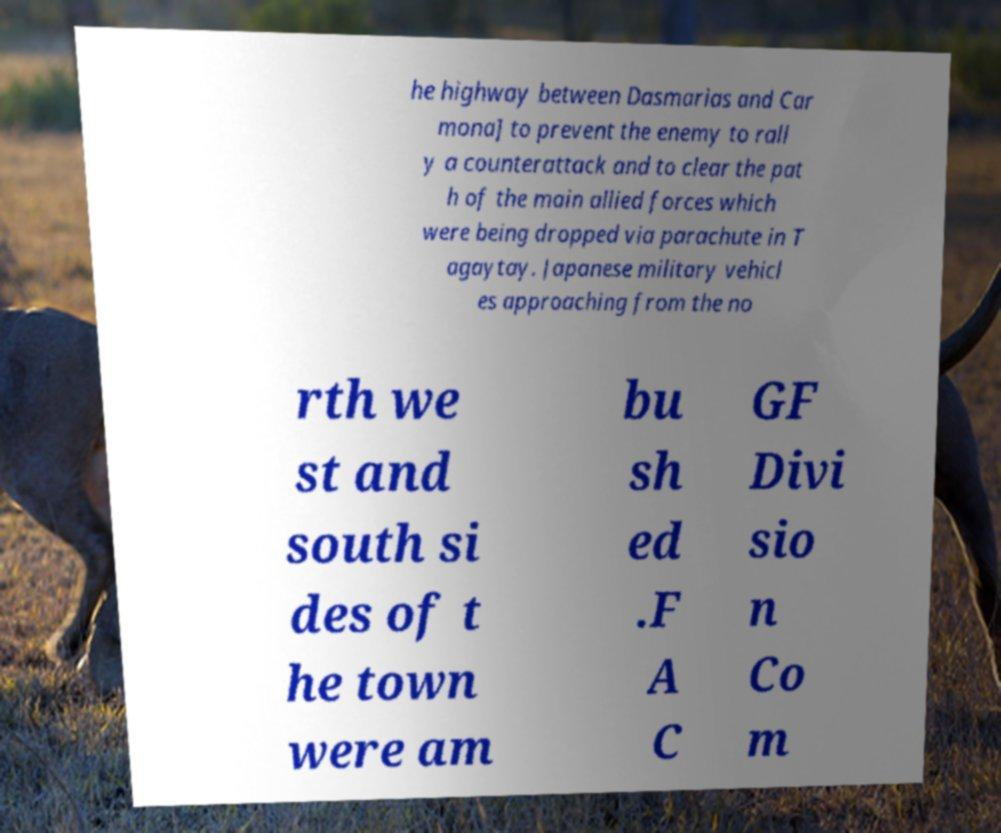What messages or text are displayed in this image? I need them in a readable, typed format. he highway between Dasmarias and Car mona] to prevent the enemy to rall y a counterattack and to clear the pat h of the main allied forces which were being dropped via parachute in T agaytay. Japanese military vehicl es approaching from the no rth we st and south si des of t he town were am bu sh ed .F A C GF Divi sio n Co m 